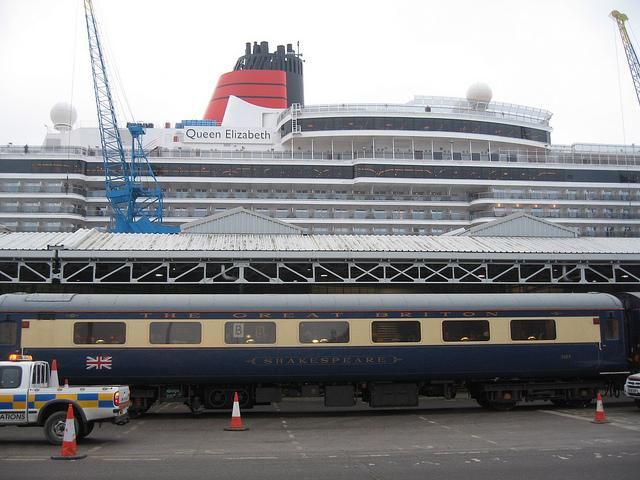The person whose name appears at the top is a descendant of whom? queen elizabeth 